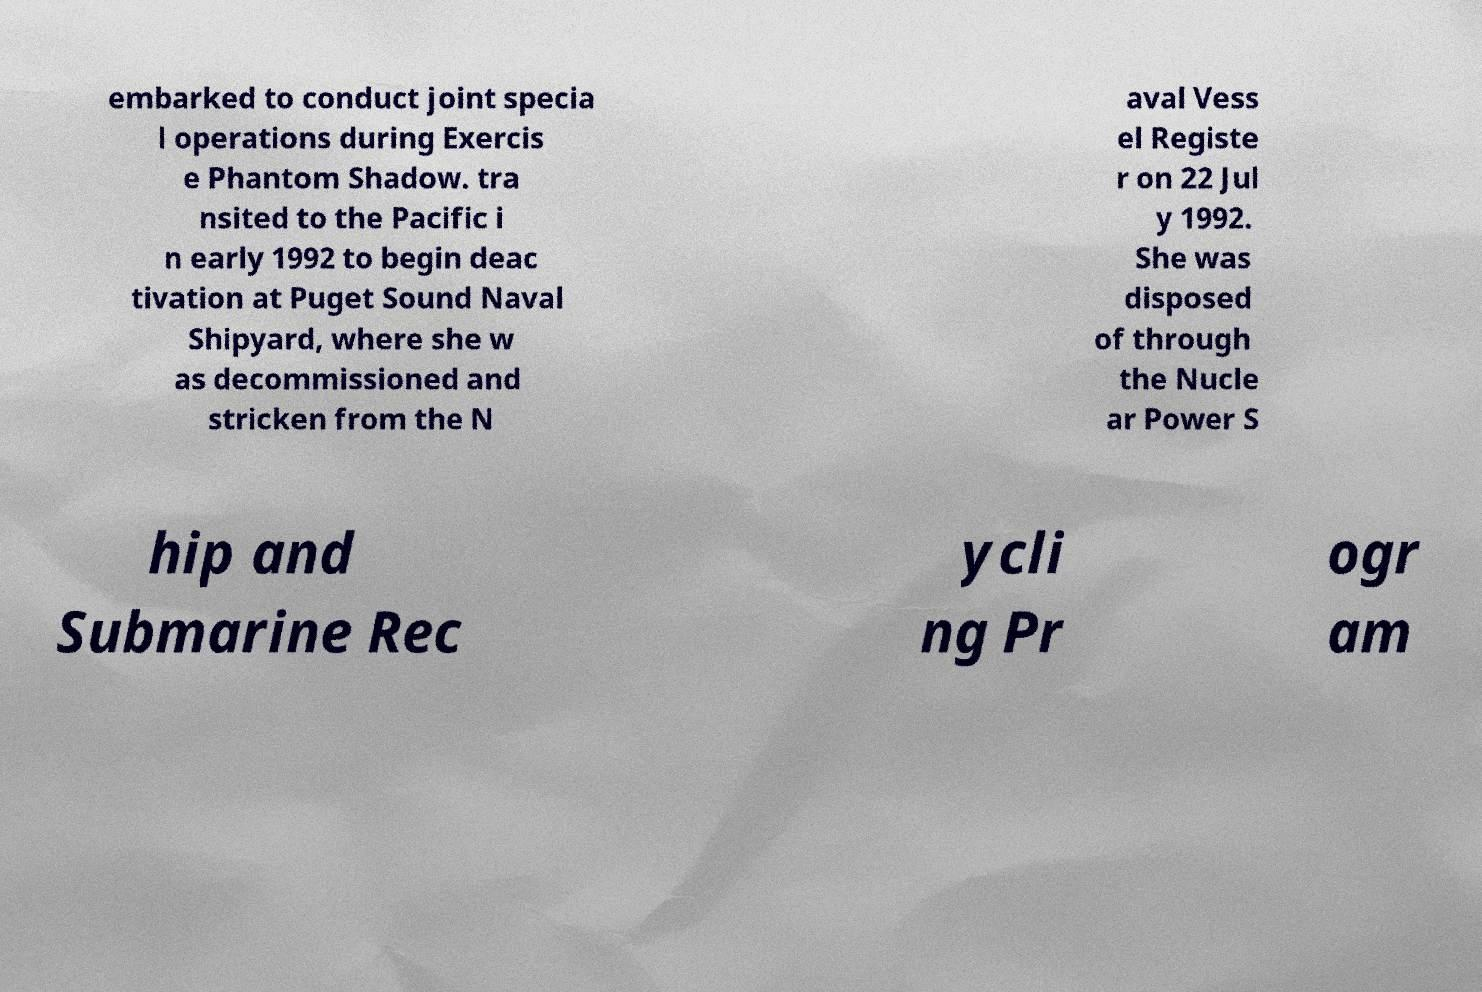I need the written content from this picture converted into text. Can you do that? embarked to conduct joint specia l operations during Exercis e Phantom Shadow. tra nsited to the Pacific i n early 1992 to begin deac tivation at Puget Sound Naval Shipyard, where she w as decommissioned and stricken from the N aval Vess el Registe r on 22 Jul y 1992. She was disposed of through the Nucle ar Power S hip and Submarine Rec ycli ng Pr ogr am 